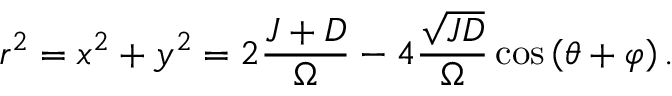Convert formula to latex. <formula><loc_0><loc_0><loc_500><loc_500>r ^ { 2 } = x ^ { 2 } + y ^ { 2 } = 2 \frac { J + D } { \Omega } - 4 \frac { \sqrt { J D } } { \Omega } \cos \left ( \theta + \varphi \right ) .</formula> 